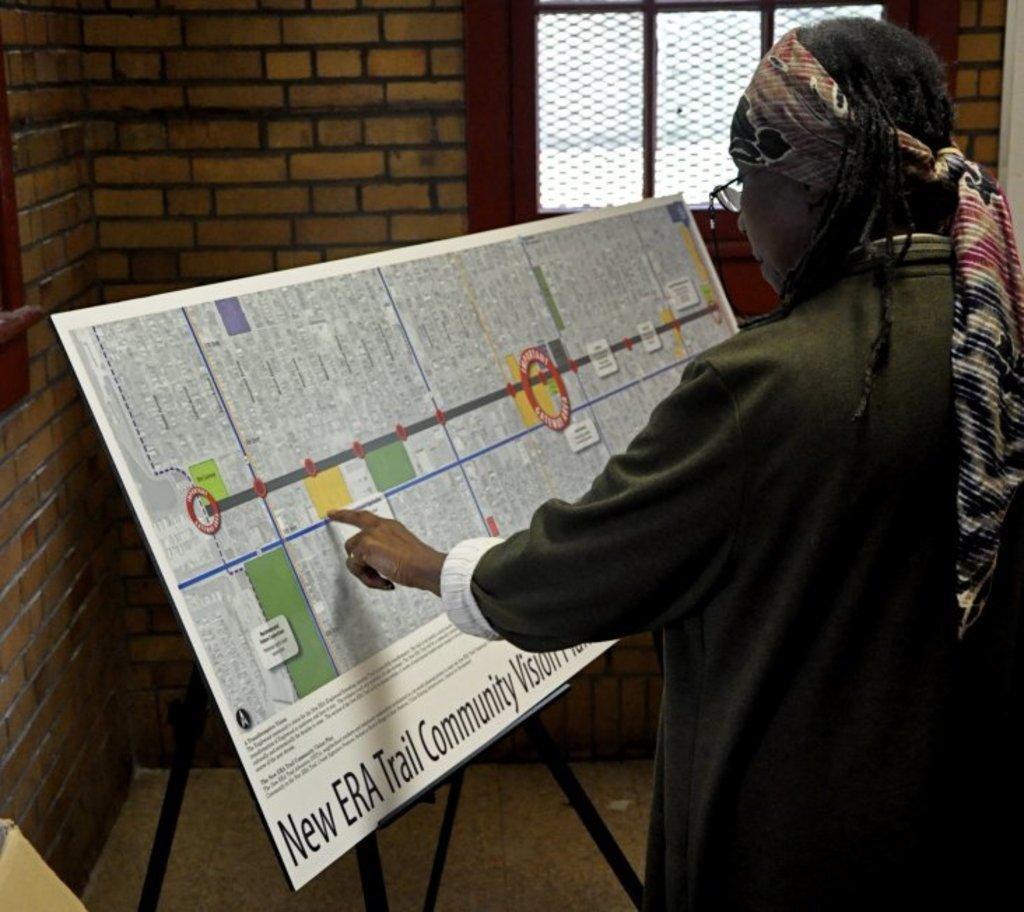Please provide a concise description of this image. In this image we can see a person is standing, who is wearing green color t-shirt and scarf on head. In front of the person one stand and board is there. Background of the image break wall and window is present. 